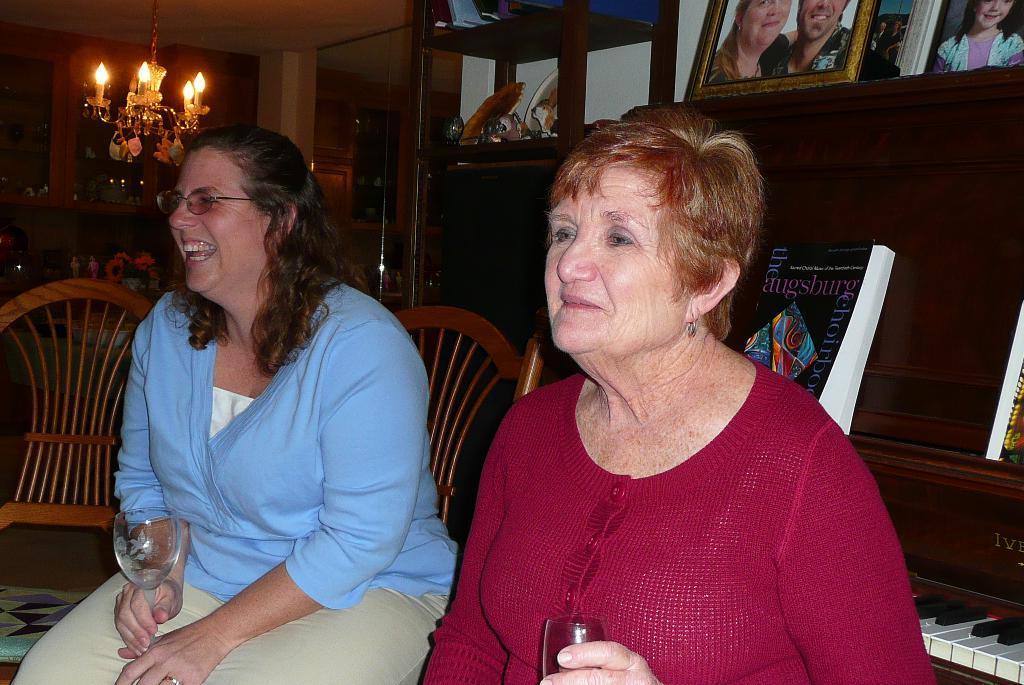In one or two sentences, can you explain what this image depicts? There are two women sitting on the chairs and holding glasses. These are the photo frames and books placed in the rack. This looks like a piano. here I can see lamp hanging to the rooftop. At background I can see cupboards with some objects. 